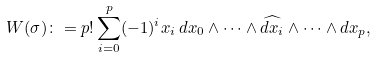Convert formula to latex. <formula><loc_0><loc_0><loc_500><loc_500>W ( \sigma ) \colon = p ! \sum _ { i = 0 } ^ { p } ( - 1 ) ^ { i } x _ { i } \, d x _ { 0 } \wedge \cdots \wedge \widehat { d x _ { i } } \wedge \cdots \wedge d x _ { p } ,</formula> 